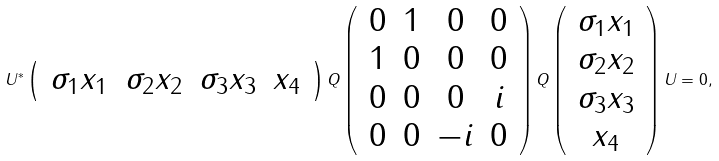<formula> <loc_0><loc_0><loc_500><loc_500>U ^ { * } \left ( \, \begin{array} { c c c c } \sigma _ { 1 } x _ { 1 } & \sigma _ { 2 } x _ { 2 } & \sigma _ { 3 } x _ { 3 } & x _ { 4 } \end{array} \, \right ) Q \left ( \, \begin{array} { c c c c } 0 & 1 & 0 & 0 \\ 1 & 0 & 0 & 0 \\ 0 & 0 & 0 & i \\ 0 & 0 & - i & 0 \end{array} \, \right ) Q \left ( \, \begin{array} { c } \sigma _ { 1 } x _ { 1 } \\ \sigma _ { 2 } x _ { 2 } \\ \sigma _ { 3 } x _ { 3 } \\ x _ { 4 } \end{array} \, \right ) U = 0 ,</formula> 